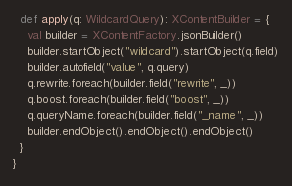<code> <loc_0><loc_0><loc_500><loc_500><_Scala_>  def apply(q: WildcardQuery): XContentBuilder = {
    val builder = XContentFactory.jsonBuilder()
    builder.startObject("wildcard").startObject(q.field)
    builder.autofield("value", q.query)
    q.rewrite.foreach(builder.field("rewrite", _))
    q.boost.foreach(builder.field("boost", _))
    q.queryName.foreach(builder.field("_name", _))
    builder.endObject().endObject().endObject()
  }
}
</code> 